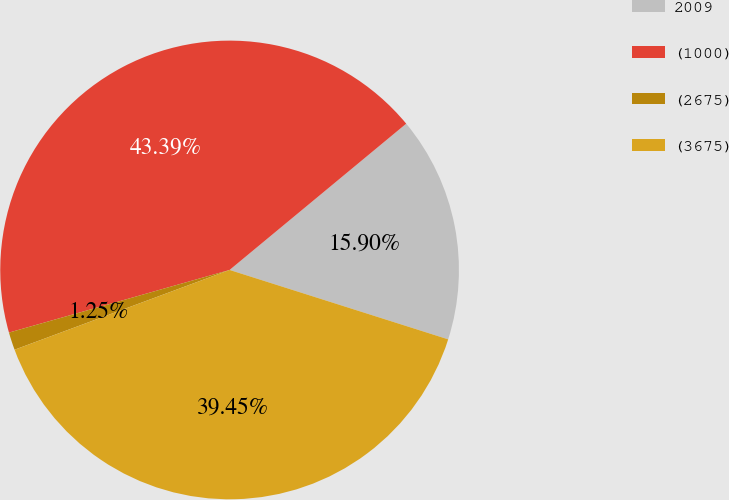Convert chart to OTSL. <chart><loc_0><loc_0><loc_500><loc_500><pie_chart><fcel>2009<fcel>(1000)<fcel>(2675)<fcel>(3675)<nl><fcel>15.9%<fcel>43.39%<fcel>1.25%<fcel>39.45%<nl></chart> 